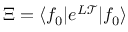<formula> <loc_0><loc_0><loc_500><loc_500>\Xi = \langle f _ { 0 } | e ^ { L \mathcal { T } } | f _ { 0 } \rangle</formula> 